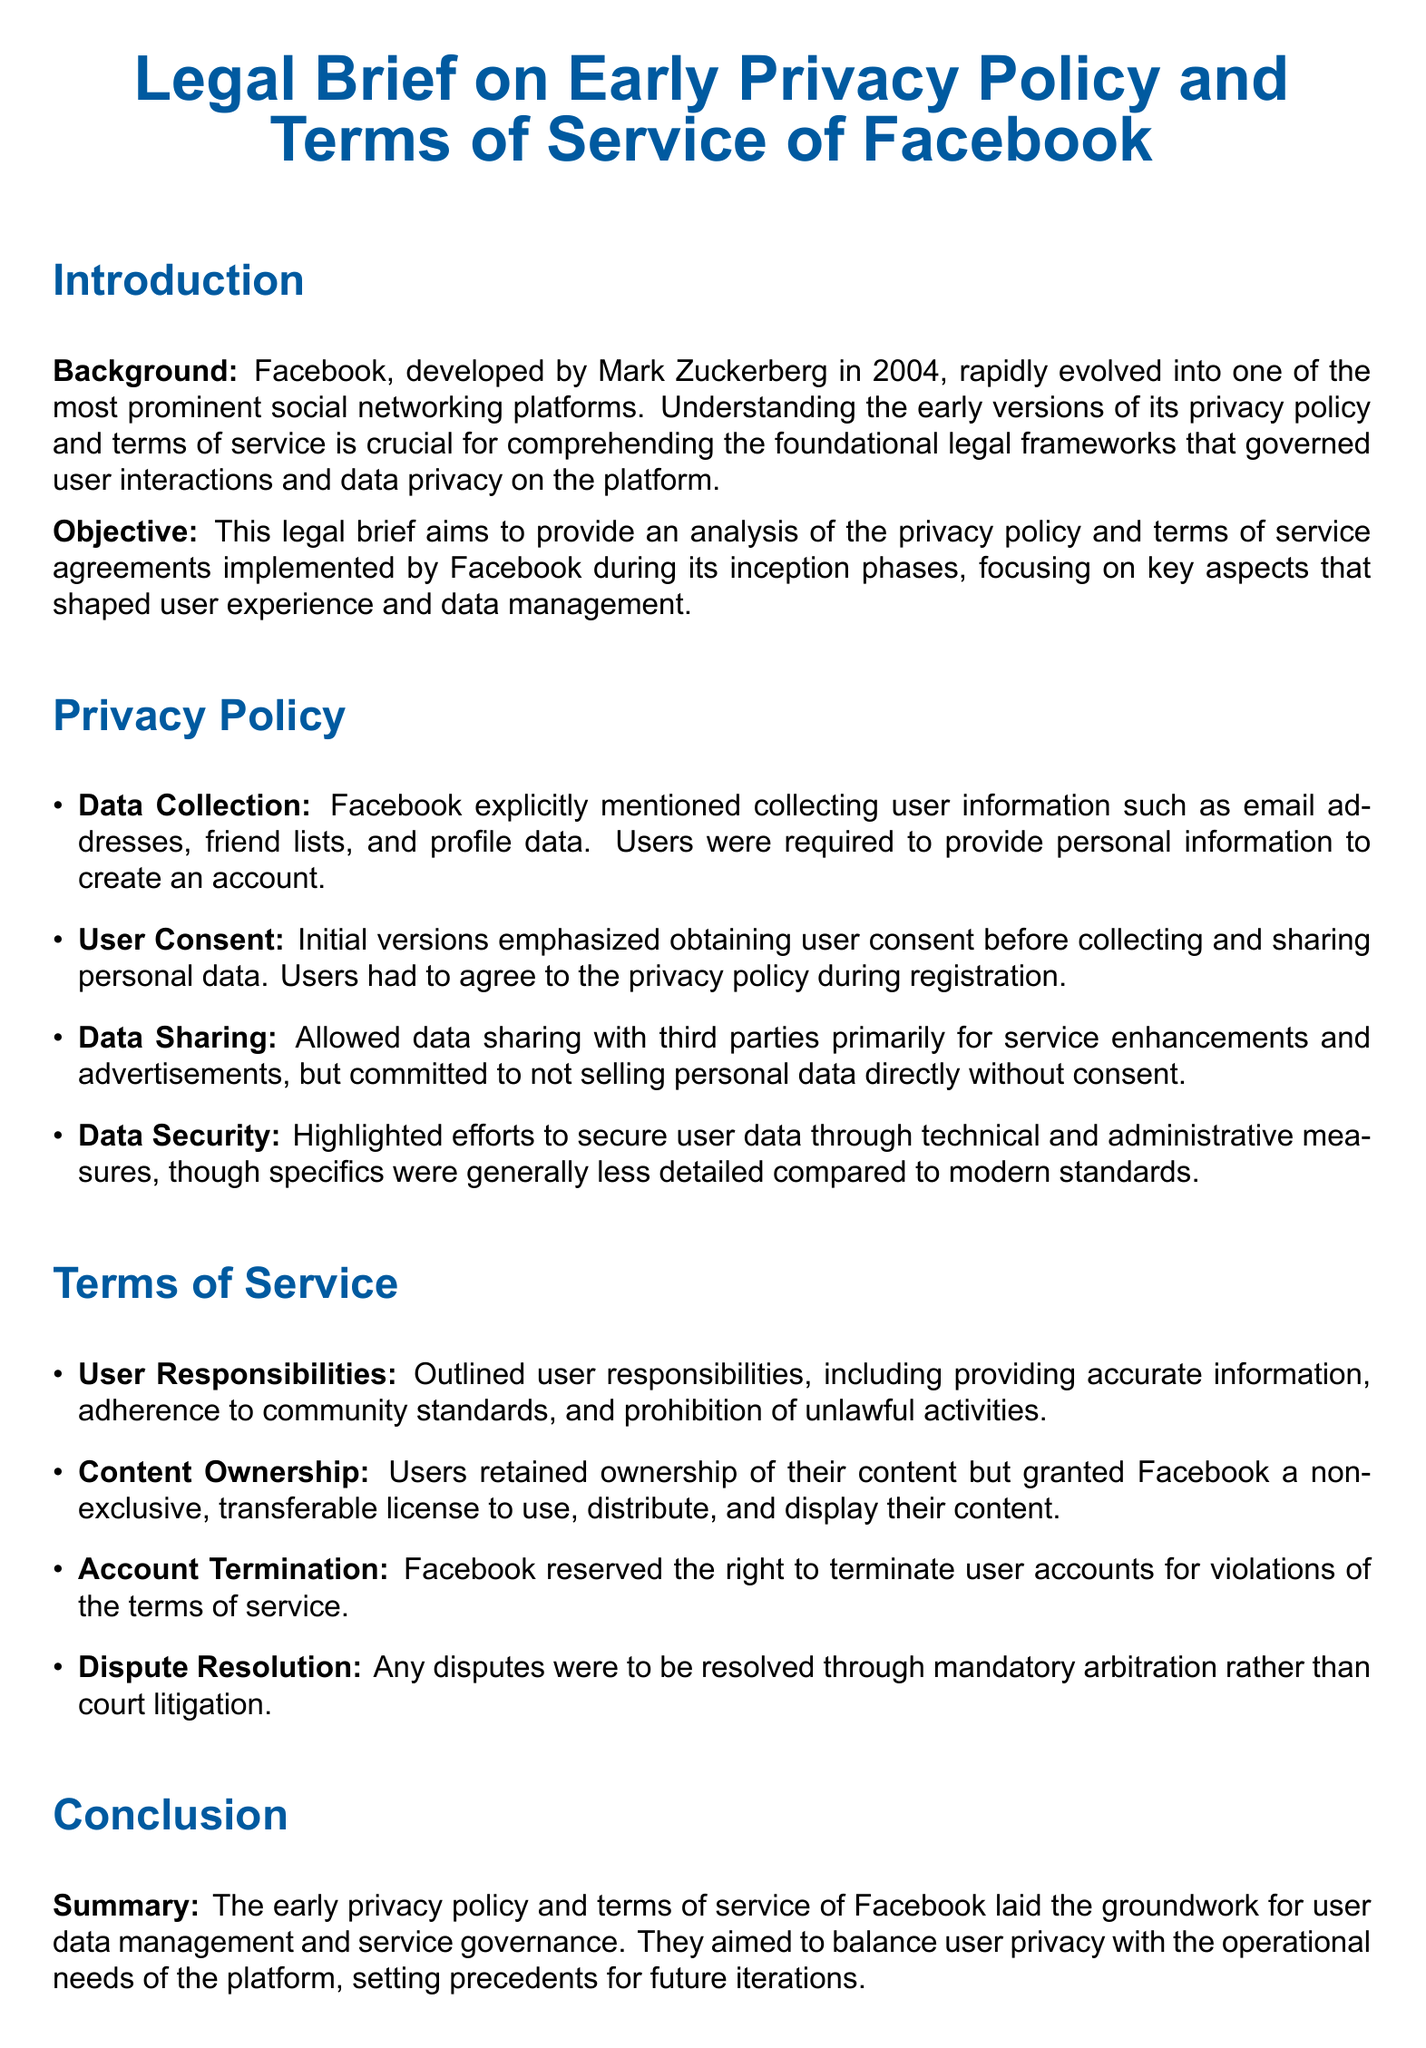What year was Facebook developed? The document states that Facebook was developed by Mark Zuckerberg in 2004.
Answer: 2004 What type of license do users grant Facebook for their content? The terms of service specify that users grant Facebook a non-exclusive, transferable license to use, distribute, and display their content.
Answer: Non-exclusive, transferable license What was the requirement for users to create an account? The privacy policy mentions that users were required to provide personal information to create an account.
Answer: Personal information What does the early privacy policy commit regarding the selling of personal data? It committed to not selling personal data directly without consent.
Answer: Not selling without consent What is emphasized before collecting user data? The privacy policy emphasized obtaining user consent before collecting and sharing personal data.
Answer: User consent Under what condition can Facebook terminate user accounts? The terms of service outline that Facebook can terminate accounts for violations of the terms of service.
Answer: Violations of terms What is the approach to dispute resolution mentioned in the document? The terms of service state that disputes were to be resolved through mandatory arbitration.
Answer: Mandatory arbitration What aspects did the early privacy policy aim to balance? The early privacy policy aimed to balance user privacy with the operational needs of the platform.
Answer: User privacy and operational needs What type of information is specified as collected by Facebook? The privacy policy specifies collecting user information such as email addresses, friend lists, and profile data.
Answer: Email addresses, friend lists, profile data 